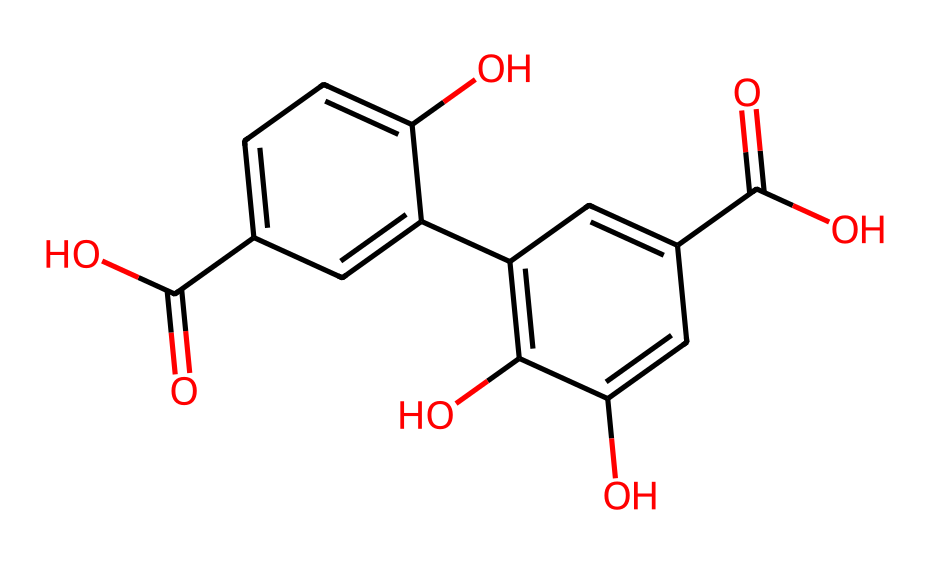What is the primary functional group present in this chemical? The chemical contains carboxylic acid groups, indicated by the –COOH functional groups attached to the benzene rings.
Answer: carboxylic acid How many rings are present in the structure? By analyzing the SMILES representation, the structure reveals two aromatic rings linked through a network of bonds, indicating there are two rings.
Answer: two What type of interactions can this chemical facilitate in water purification? The presence of polar functional groups, primarily –OH and –COOH, suggests it can engage in hydrogen bonding and electrostatic interactions with water and contaminants in filtration systems.
Answer: hydrogen bonding What is the total number of carbon atoms in the molecule? Counting the carbon atoms in the structure from the SMILES, we find a total of fifteen carbon atoms (C).
Answer: fifteen Can this molecule participate in π-π stacking interactions? Yes, the aromatic rings present in the structure allow for π-π stacking interactions between adjacent molecules, enhancing their effectiveness in water purification applications.
Answer: yes How might the presence of hydroxyl groups influence the solubility of this chemical in water? The hydroxyl groups (–OH) increase the polarity of the molecule, thus enhancing its solubility in water, making it more effective in filtration systems.
Answer: enhance solubility 